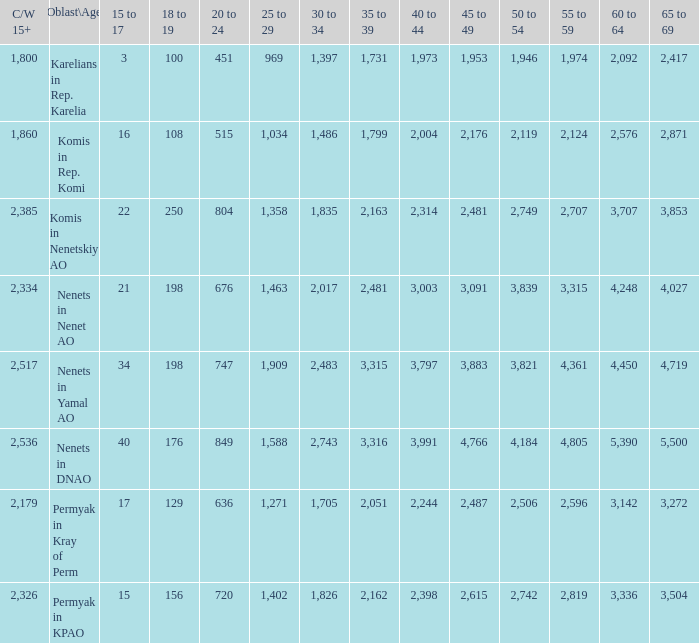What is the total 60 to 64 when the Oblast\Age is Nenets in Yamal AO, and the 45 to 49 is bigger than 3,883? None. 